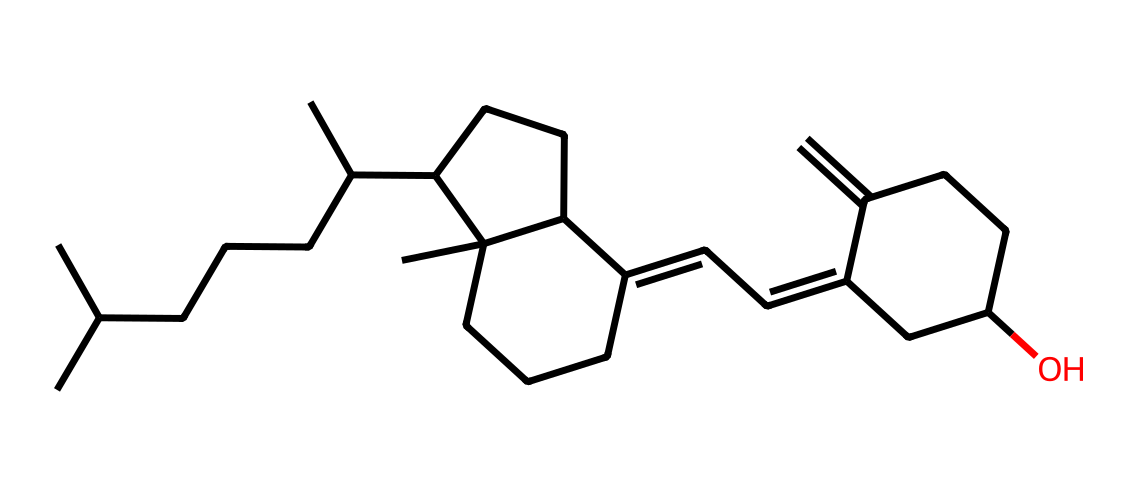What is the common name of this vitamin? Based on the provided SMILES structure, this compound corresponds to vitamin D, which is commonly known for its role in calcium metabolism and bone health.
Answer: vitamin D How many carbon atoms are in the structure? By analyzing the SMILES representation, we count the number of carbon (C) atoms present, which totals to 27.
Answer: 27 What role does vitamin D play in nutrition? Vitamin D is crucial for calcium absorption in the gut, which is vital for maintaining bone health and preventing nutritional deficiencies.
Answer: calcium absorption Is this compound hydrophobic or hydrophilic? Observing the structure, it predominantly consists of hydrocarbon chains and lacks polar functional groups, indicating it is hydrophobic.
Answer: hydrophobic What type of bond primarily characterizes the structure of vitamin D? The structure contains a significant number of single and double carbon-carbon bonds, typical of steroids, indicating predominantly covalent bonds.
Answer: covalent bonds In legal cases, how is vitamin D deficiency classified? Legal cases often classify vitamin D deficiency as a nutritional deficiency due to its significant role in health and its absence leading to legal implications regarding dietary standards.
Answer: nutritional deficiency 